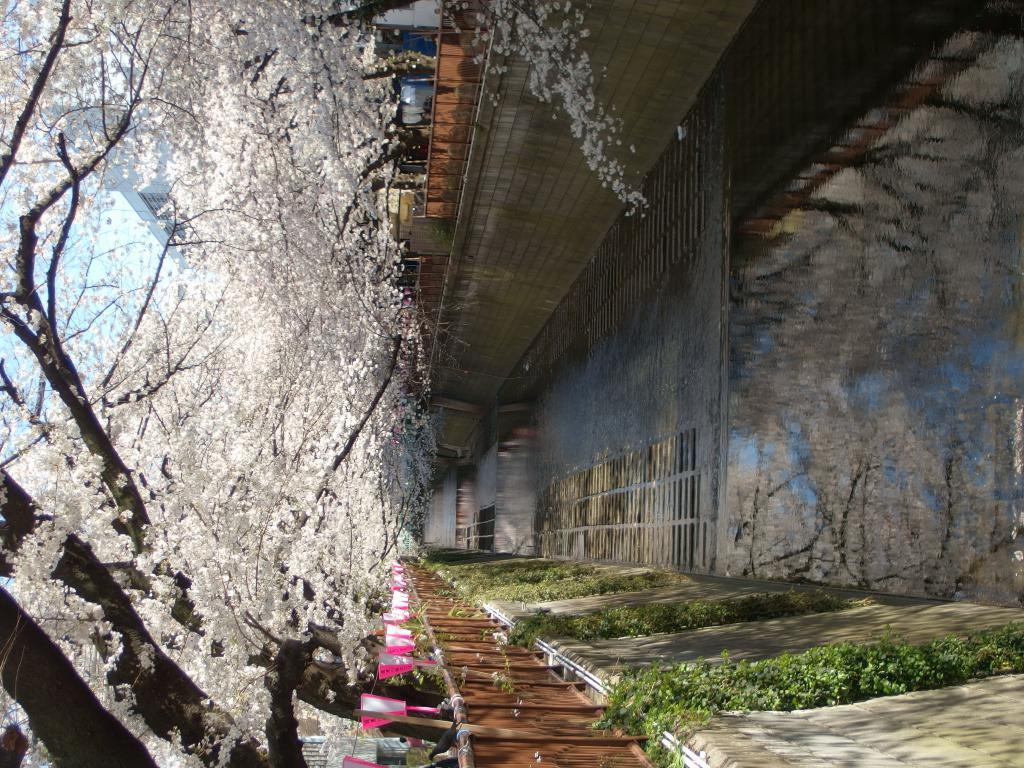What type of structure is visible in the image? There is a building in the image. What feature can be seen near the building? There is railing in the image. What type of vegetation is present in the image? There are trees in the image. What can be seen in the distance in the image? The sky is visible in the background of the image. What type of jeans is the tree wearing in the image? There are no jeans present in the image, as trees are not capable of wearing clothing. 